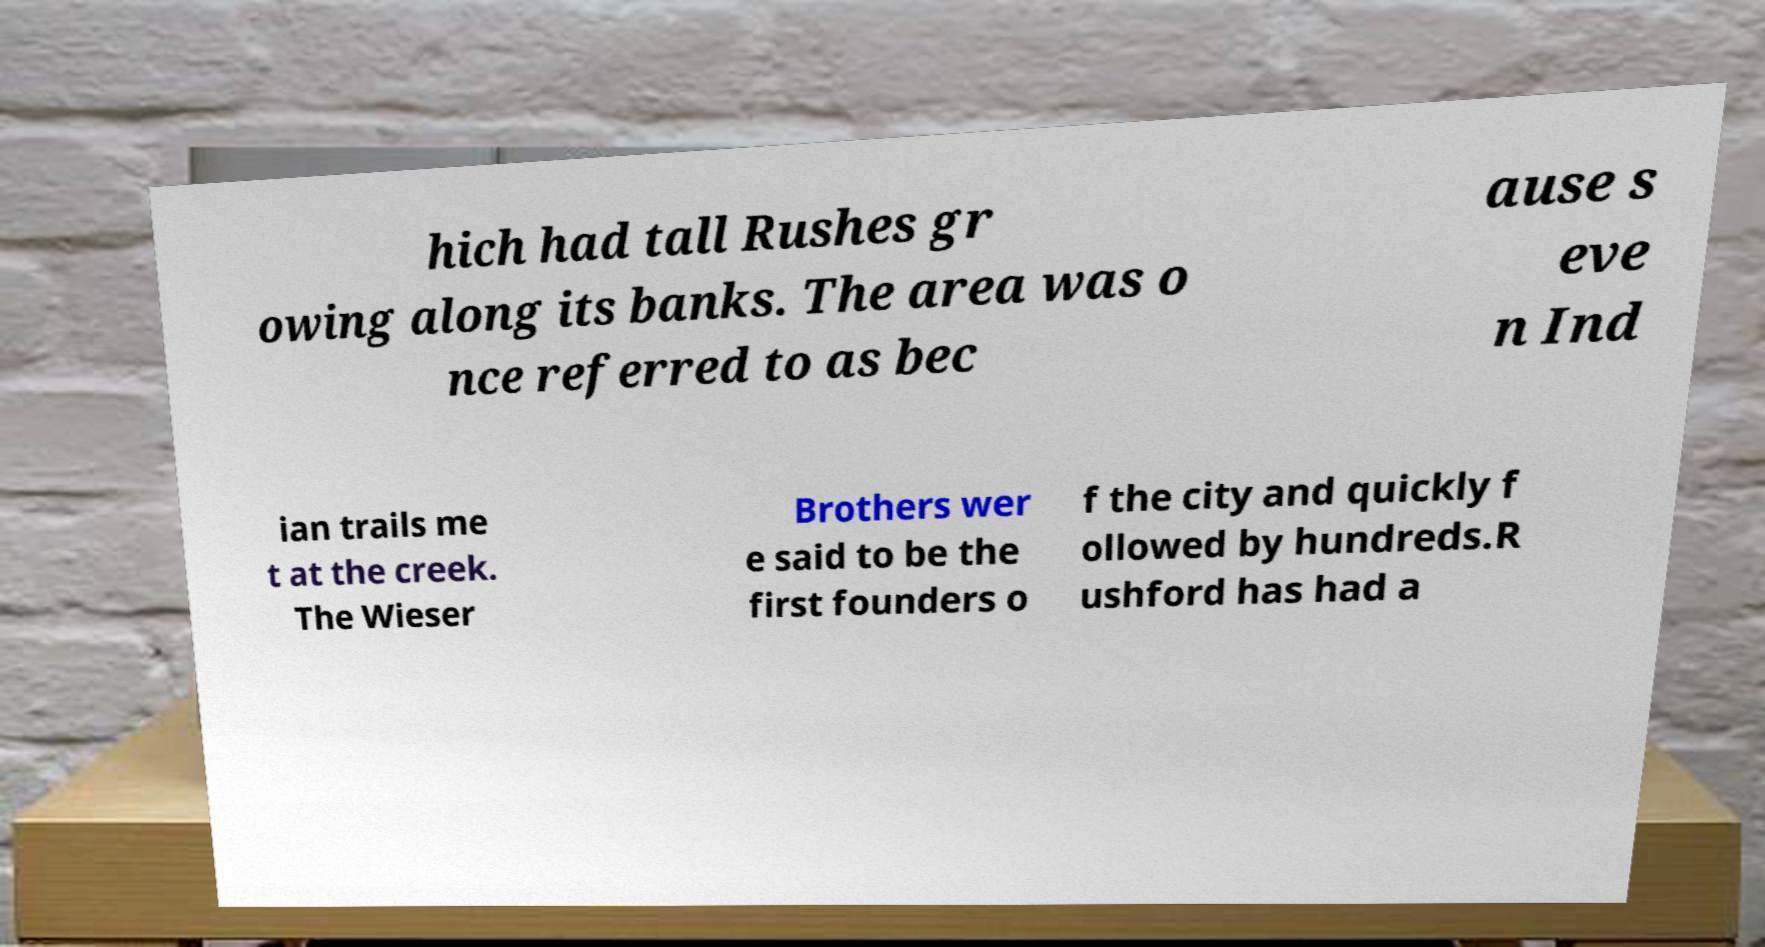There's text embedded in this image that I need extracted. Can you transcribe it verbatim? hich had tall Rushes gr owing along its banks. The area was o nce referred to as bec ause s eve n Ind ian trails me t at the creek. The Wieser Brothers wer e said to be the first founders o f the city and quickly f ollowed by hundreds.R ushford has had a 